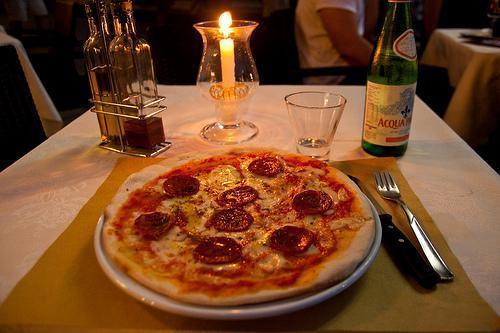How many pizzas are there?
Give a very brief answer. 1. 